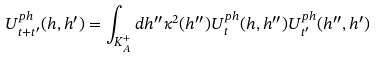<formula> <loc_0><loc_0><loc_500><loc_500>U _ { t + t ^ { \prime } } ^ { p h } ( h , h ^ { \prime } ) = \int _ { K _ { A } ^ { + } } d h ^ { \prime \prime } \kappa ^ { 2 } ( h ^ { \prime \prime } ) U _ { t } ^ { p h } ( h , h ^ { \prime \prime } ) U _ { t ^ { \prime } } ^ { p h } ( h ^ { \prime \prime } , h ^ { \prime } )</formula> 